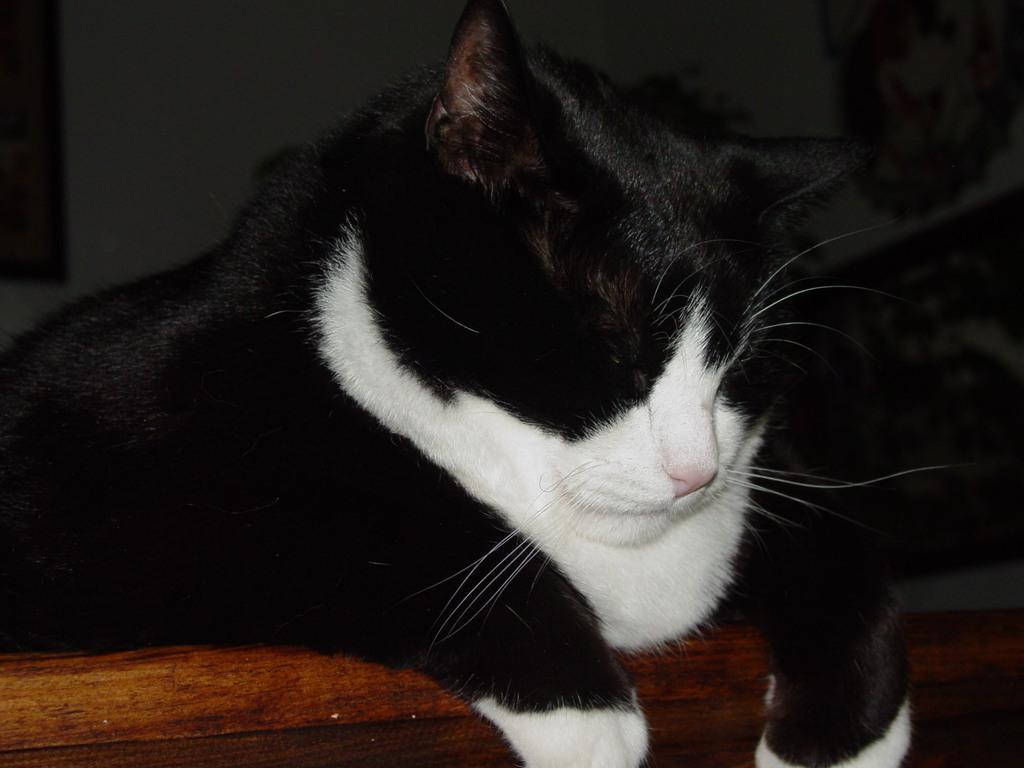In one or two sentences, can you explain what this image depicts? In the foreground of this picture, there is a cat sleeping on a wooden surface. There is a wall in the background. 